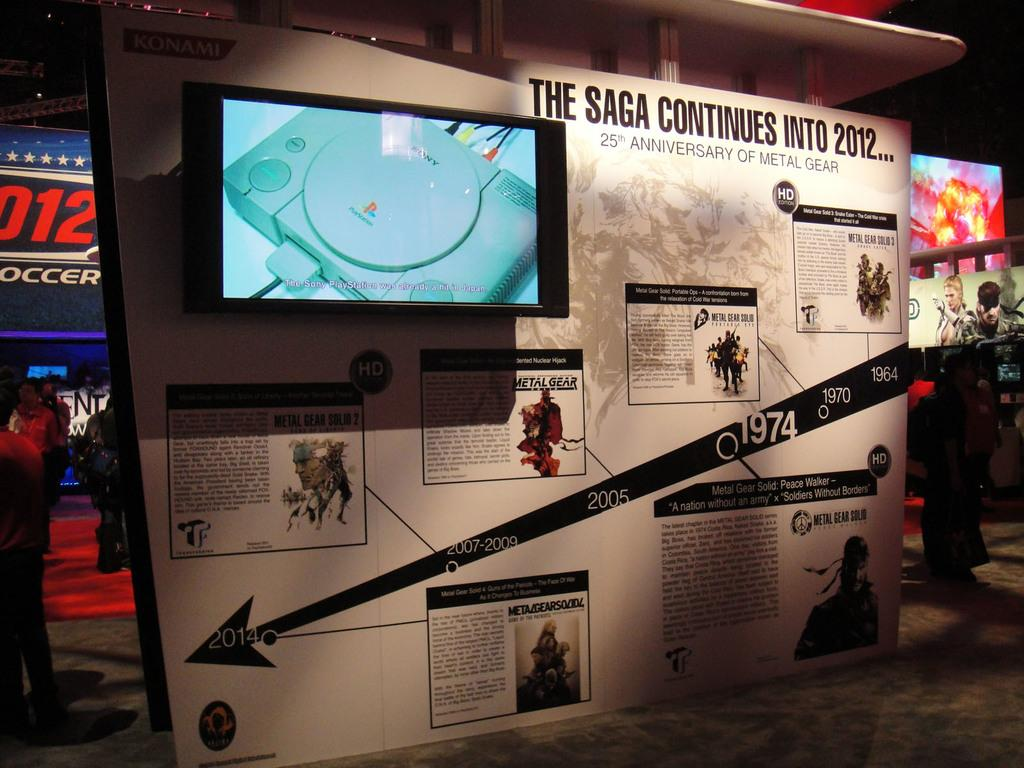<image>
Describe the image concisely. A timeline display celebrates 25 years of Metal Gear. 